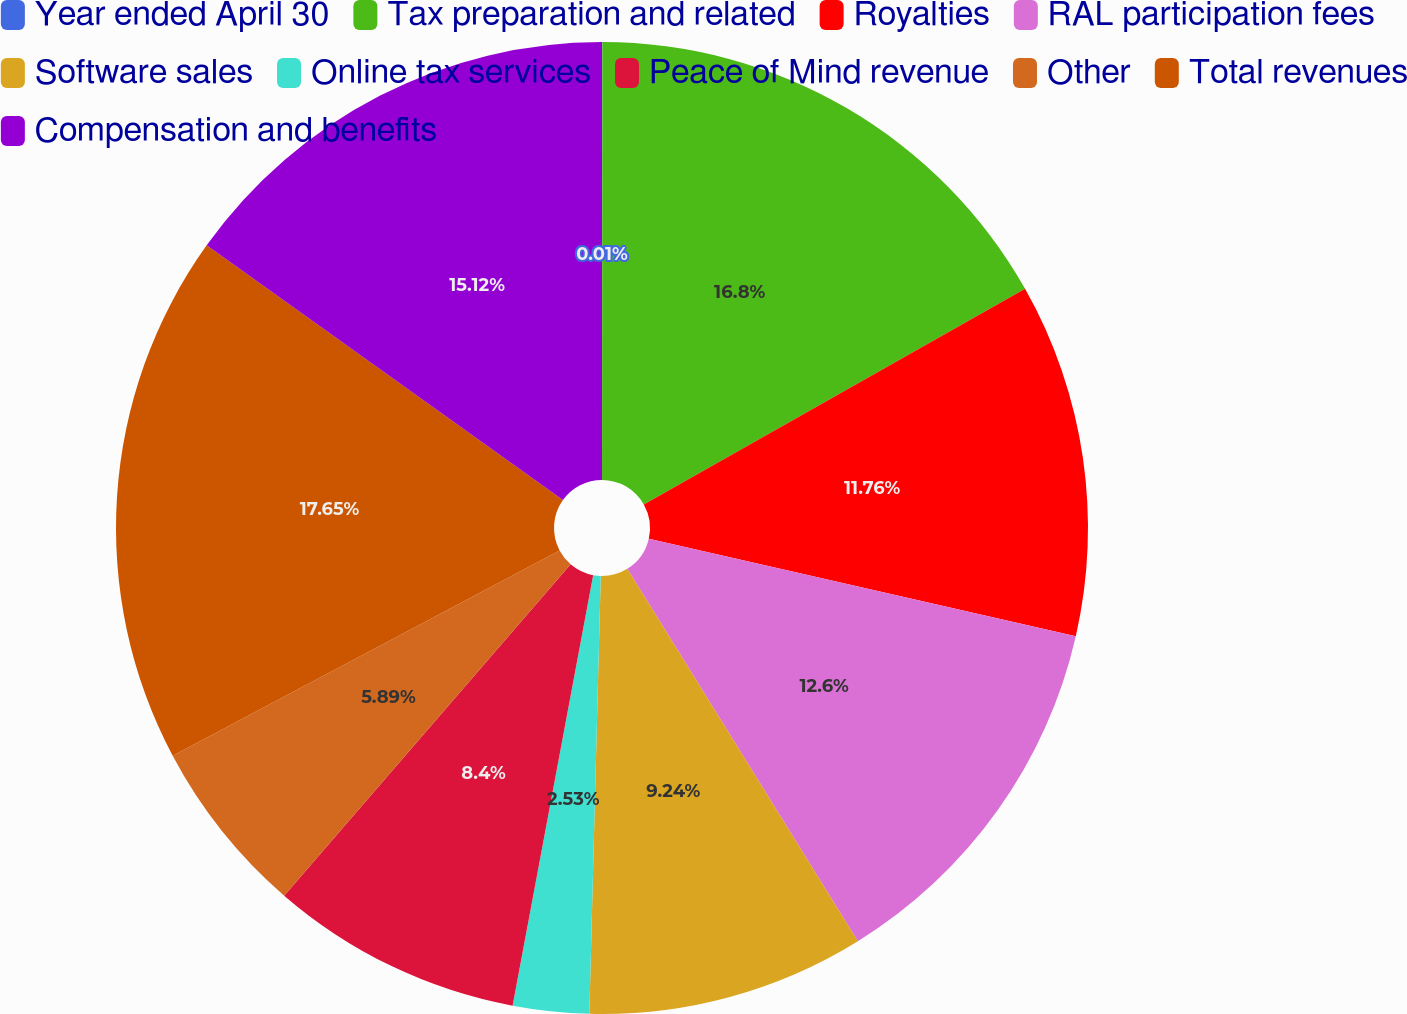Convert chart. <chart><loc_0><loc_0><loc_500><loc_500><pie_chart><fcel>Year ended April 30<fcel>Tax preparation and related<fcel>Royalties<fcel>RAL participation fees<fcel>Software sales<fcel>Online tax services<fcel>Peace of Mind revenue<fcel>Other<fcel>Total revenues<fcel>Compensation and benefits<nl><fcel>0.01%<fcel>16.8%<fcel>11.76%<fcel>12.6%<fcel>9.24%<fcel>2.53%<fcel>8.4%<fcel>5.89%<fcel>17.64%<fcel>15.12%<nl></chart> 